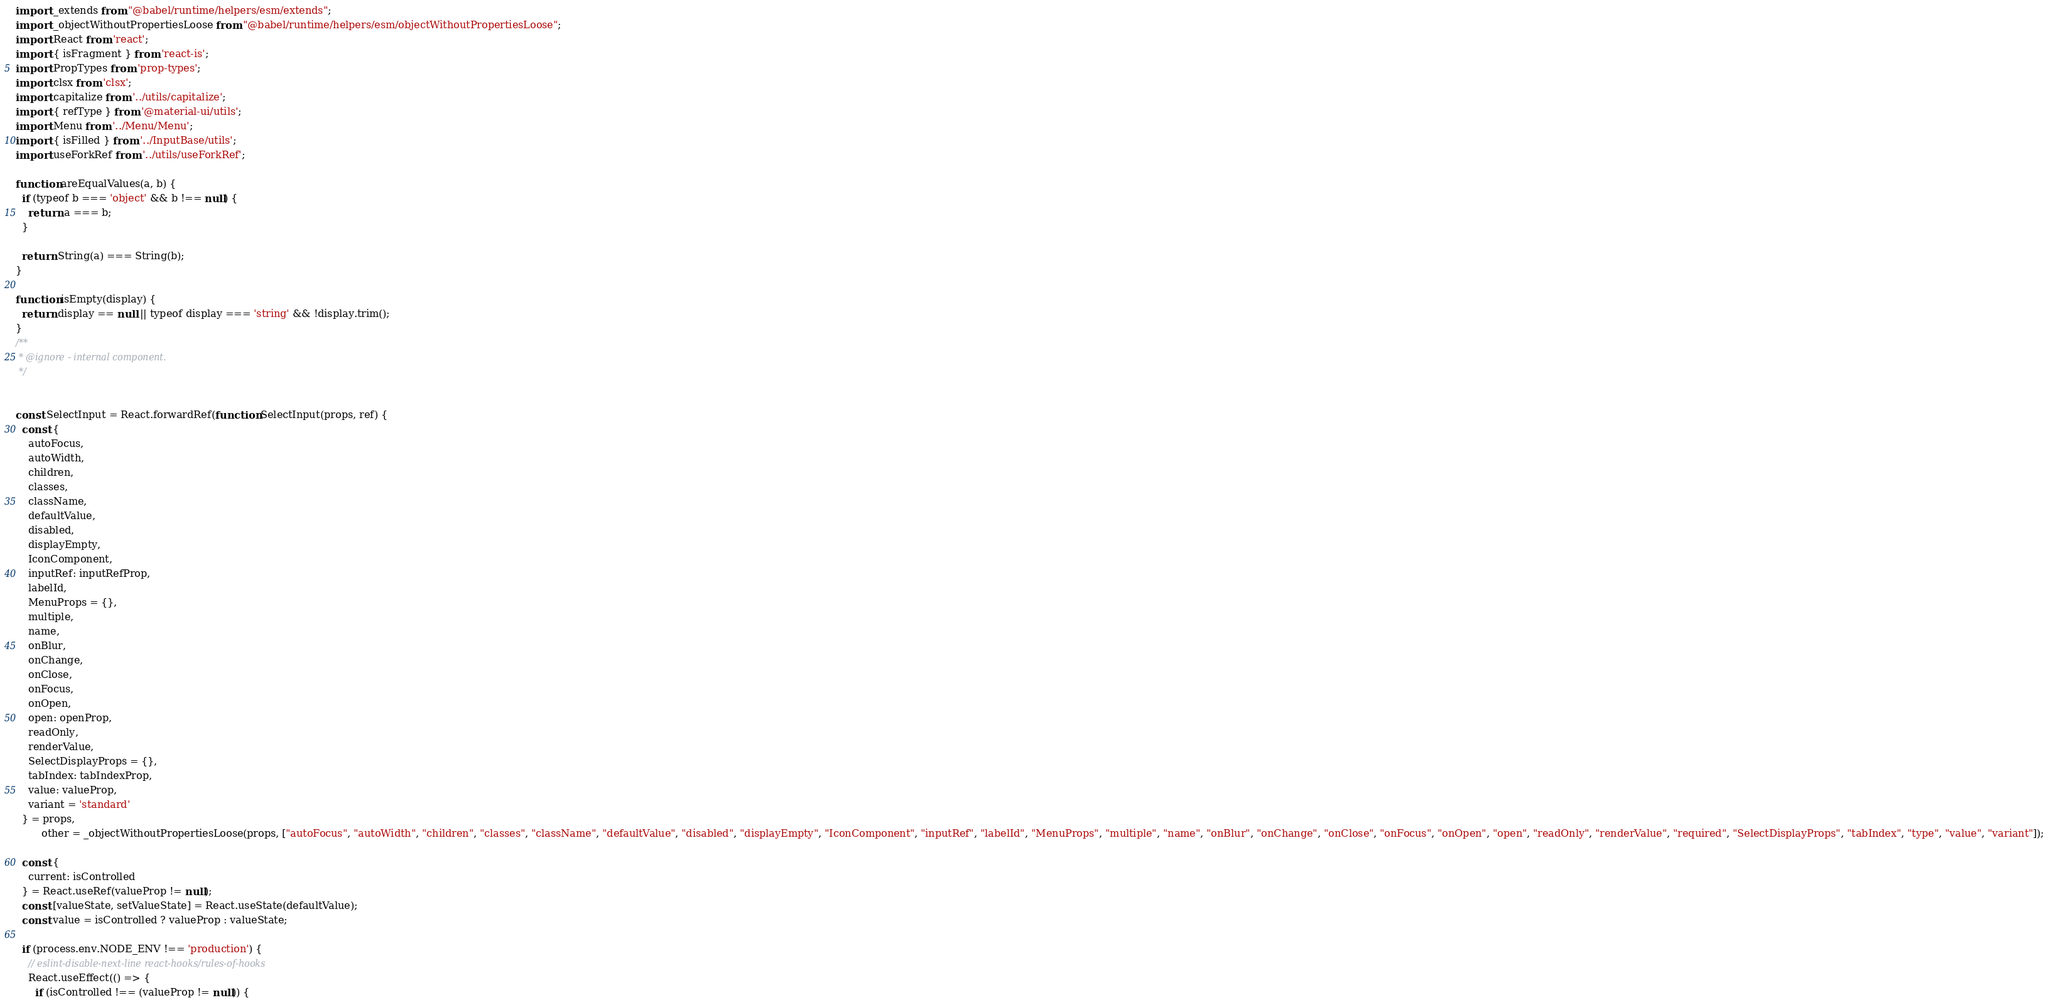<code> <loc_0><loc_0><loc_500><loc_500><_JavaScript_>import _extends from "@babel/runtime/helpers/esm/extends";
import _objectWithoutPropertiesLoose from "@babel/runtime/helpers/esm/objectWithoutPropertiesLoose";
import React from 'react';
import { isFragment } from 'react-is';
import PropTypes from 'prop-types';
import clsx from 'clsx';
import capitalize from '../utils/capitalize';
import { refType } from '@material-ui/utils';
import Menu from '../Menu/Menu';
import { isFilled } from '../InputBase/utils';
import useForkRef from '../utils/useForkRef';

function areEqualValues(a, b) {
  if (typeof b === 'object' && b !== null) {
    return a === b;
  }

  return String(a) === String(b);
}

function isEmpty(display) {
  return display == null || typeof display === 'string' && !display.trim();
}
/**
 * @ignore - internal component.
 */


const SelectInput = React.forwardRef(function SelectInput(props, ref) {
  const {
    autoFocus,
    autoWidth,
    children,
    classes,
    className,
    defaultValue,
    disabled,
    displayEmpty,
    IconComponent,
    inputRef: inputRefProp,
    labelId,
    MenuProps = {},
    multiple,
    name,
    onBlur,
    onChange,
    onClose,
    onFocus,
    onOpen,
    open: openProp,
    readOnly,
    renderValue,
    SelectDisplayProps = {},
    tabIndex: tabIndexProp,
    value: valueProp,
    variant = 'standard'
  } = props,
        other = _objectWithoutPropertiesLoose(props, ["autoFocus", "autoWidth", "children", "classes", "className", "defaultValue", "disabled", "displayEmpty", "IconComponent", "inputRef", "labelId", "MenuProps", "multiple", "name", "onBlur", "onChange", "onClose", "onFocus", "onOpen", "open", "readOnly", "renderValue", "required", "SelectDisplayProps", "tabIndex", "type", "value", "variant"]);

  const {
    current: isControlled
  } = React.useRef(valueProp != null);
  const [valueState, setValueState] = React.useState(defaultValue);
  const value = isControlled ? valueProp : valueState;

  if (process.env.NODE_ENV !== 'production') {
    // eslint-disable-next-line react-hooks/rules-of-hooks
    React.useEffect(() => {
      if (isControlled !== (valueProp != null)) {</code> 